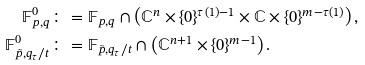<formula> <loc_0><loc_0><loc_500><loc_500>\mathbb { F } ^ { 0 } _ { p , q } & \colon = \mathbb { F } _ { p , q } \cap \left ( \mathbb { C } ^ { n } \times \{ 0 \} ^ { \tau ( 1 ) - 1 } \times \mathbb { C } \times \{ 0 \} ^ { m - \tau ( 1 ) } \right ) , \\ \mathbb { F } ^ { 0 } _ { \tilde { p } , q _ { \tau } / t } & \colon = \mathbb { F } _ { \tilde { p } , q _ { \tau } / t } \cap \left ( \mathbb { C } ^ { n + 1 } \times \{ 0 \} ^ { m - 1 } \right ) .</formula> 